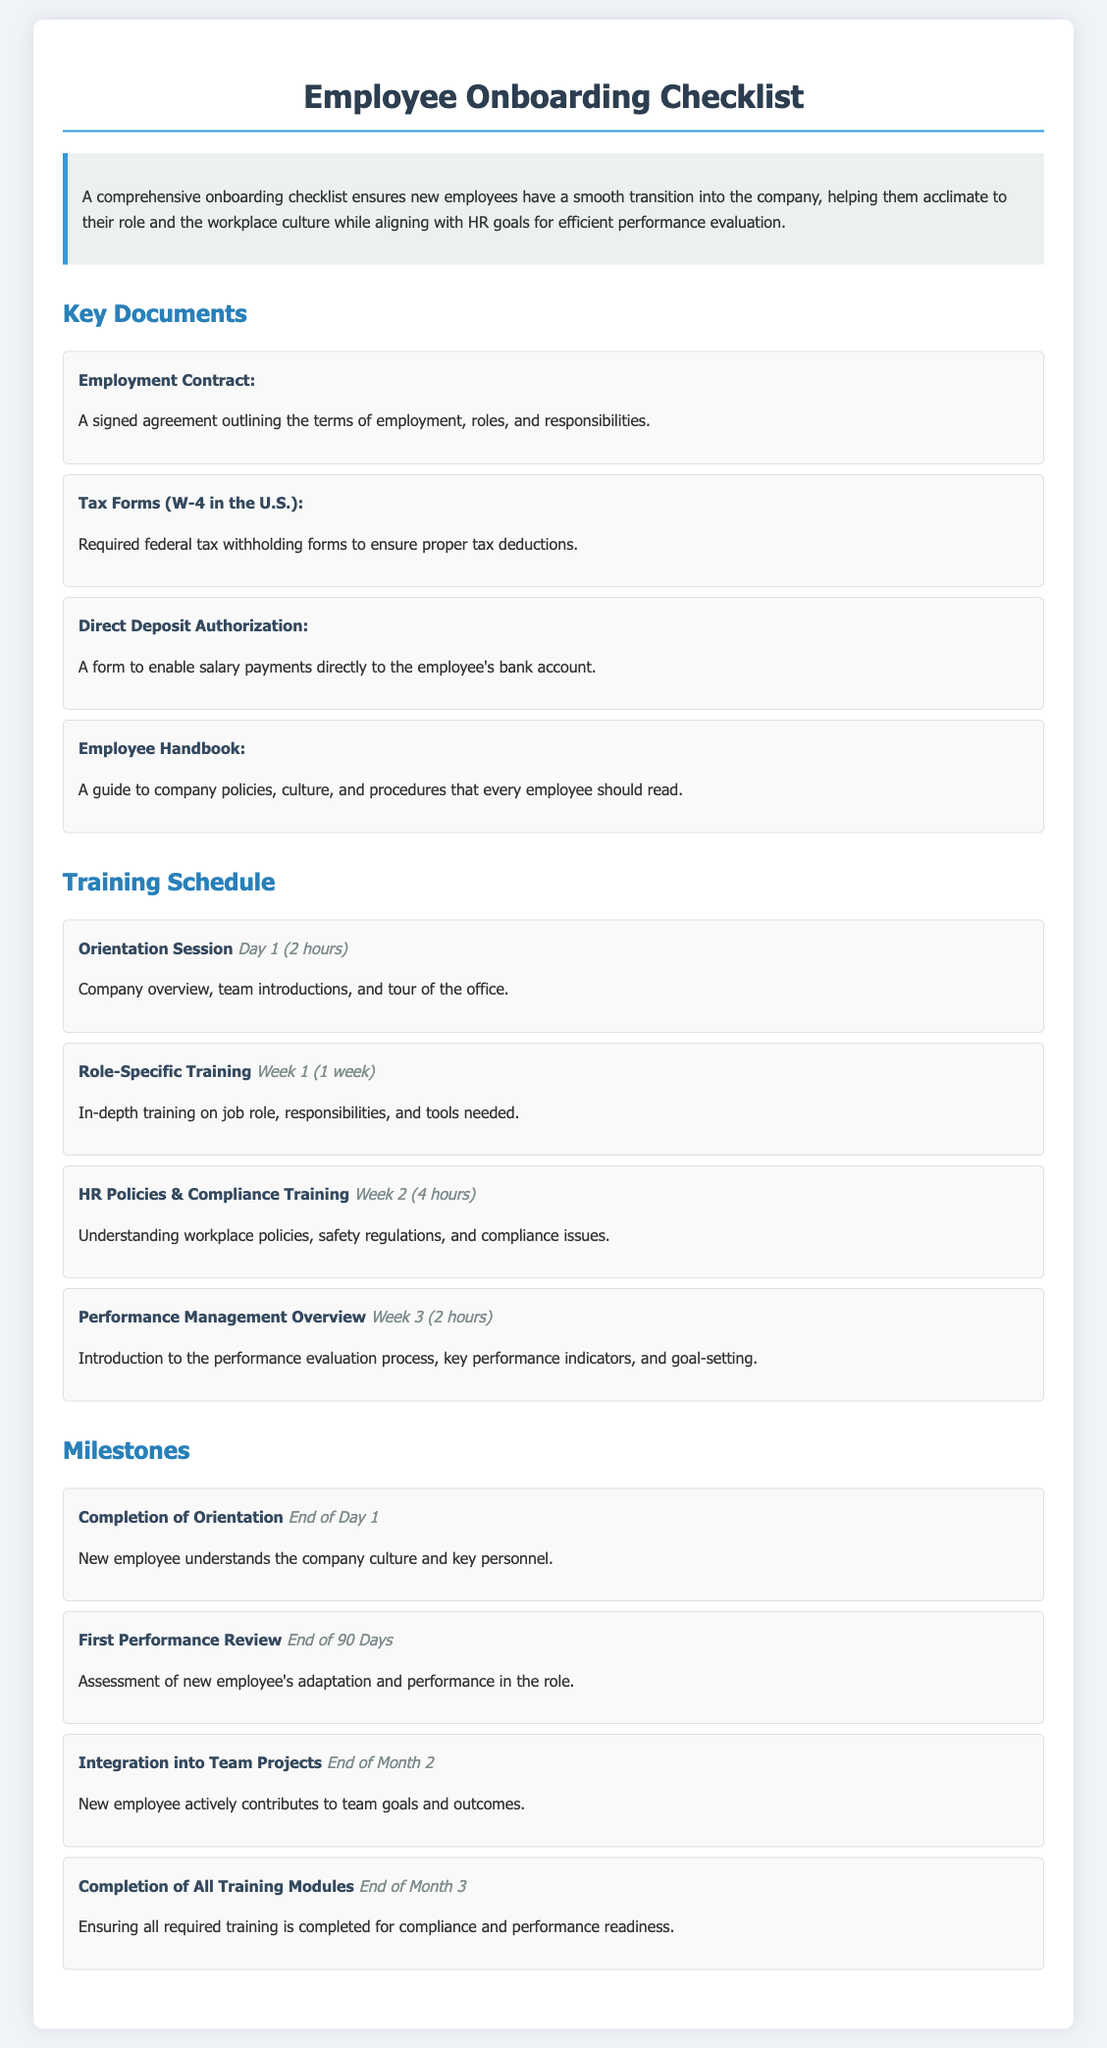What is the first document listed in the Key Documents section? The first document listed is the Employment Contract, which outlines the terms of employment, roles, and responsibilities.
Answer: Employment Contract How long is the Orientation Session? The Orientation Session is scheduled for Day 1 and lasts for 2 hours.
Answer: 2 hours What is the milestone date for the Completion of Orientation? The Completion of Orientation is marked as a milestone at the End of Day 1.
Answer: End of Day 1 Which training session focuses on performance evaluation? The training session that focuses on performance evaluation is titled Performance Management Overview.
Answer: Performance Management Overview How many training sessions are listed in the Training Schedule section? There are a total of four training sessions listed in the Training Schedule section.
Answer: Four What document provides guidance on company policies? The document that provides guidance on company policies is the Employee Handbook.
Answer: Employee Handbook At which week does Role-Specific Training occur? Role-Specific Training occurs in Week 1.
Answer: Week 1 What is the last milestone mentioned in the Milestones section? The last milestone mentioned is Completion of All Training Modules, due at the End of Month 3.
Answer: Completion of All Training Modules 